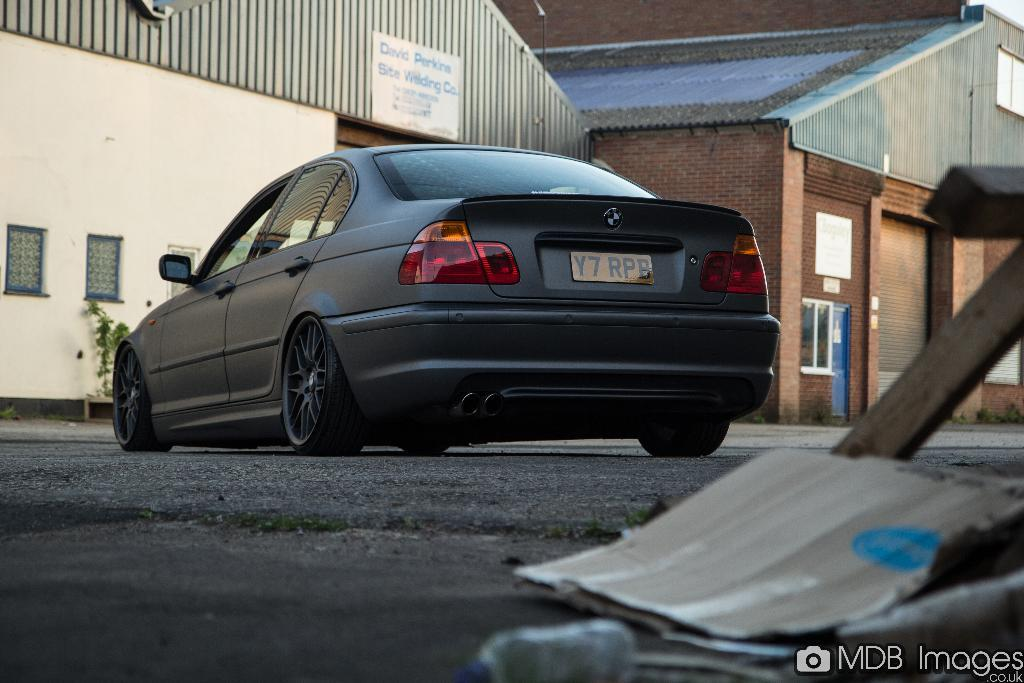What is the main subject of the image? The main subject of the image is a car. Where is the car located in the image? The car is on the road in the image. What can be seen in the background of the image? There are houses in the background of the image. Is there any text present in the image? Yes, there is text at the bottom of the image. What type of paste is being used to stick the calendar on the wall in the image? There is no calendar or paste present in the image. How does the car change its appearance in the image? The car does not change its appearance in the image; it remains stationary on the road. 